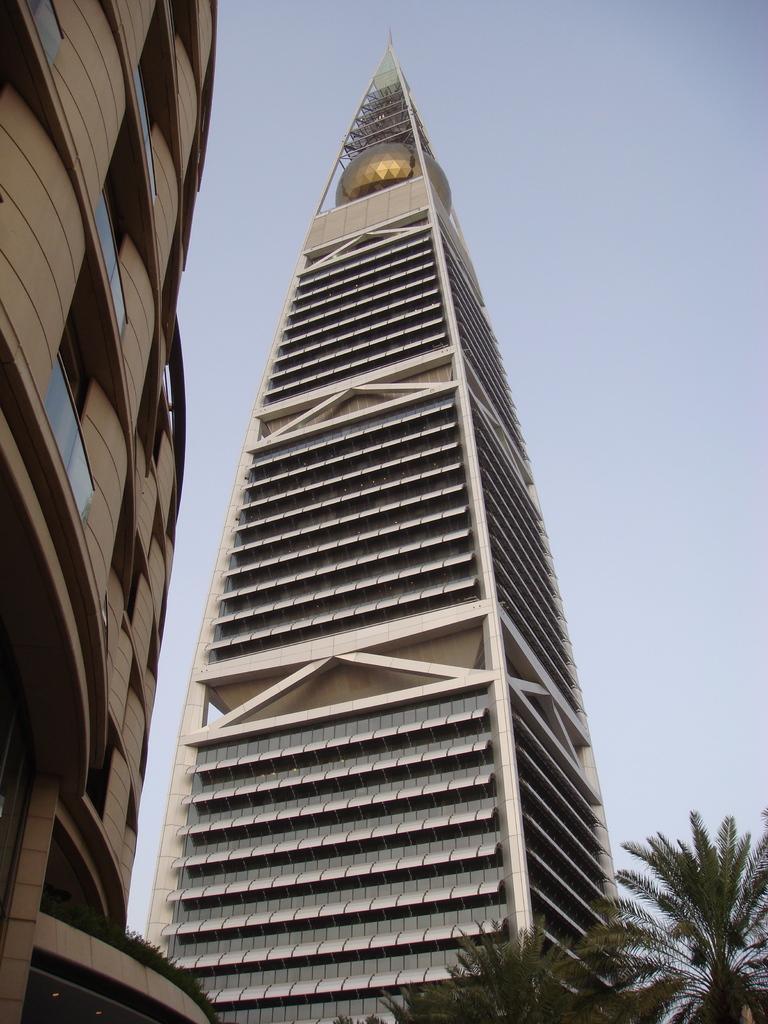Describe this image in one or two sentences. In this image, I can see the skyscraper and the building with windows. These are the trees. This is the sky. 